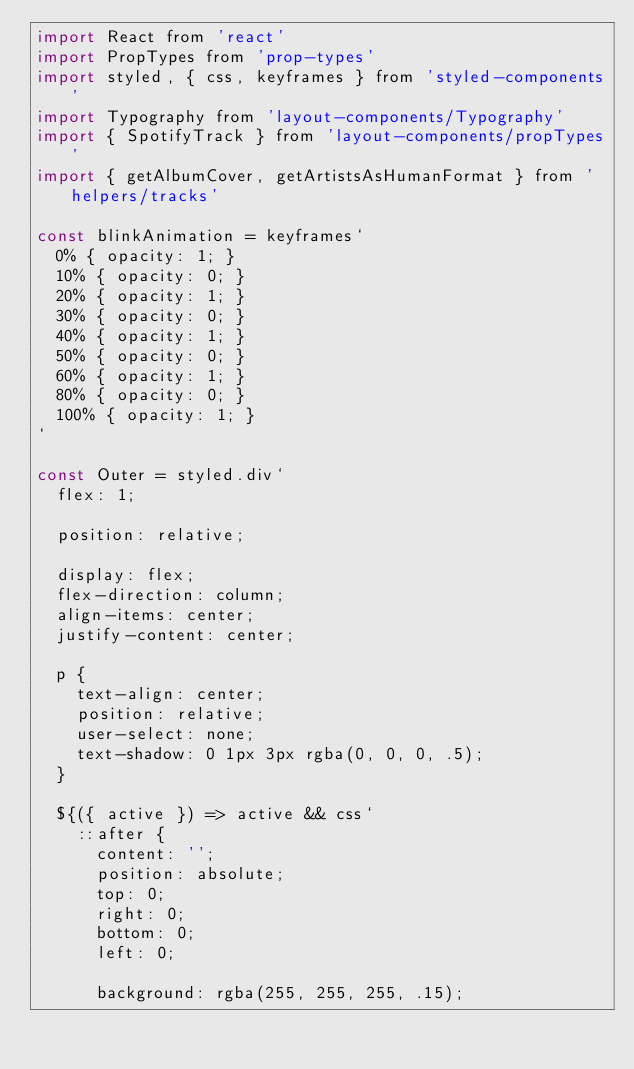<code> <loc_0><loc_0><loc_500><loc_500><_JavaScript_>import React from 'react'
import PropTypes from 'prop-types'
import styled, { css, keyframes } from 'styled-components'
import Typography from 'layout-components/Typography'
import { SpotifyTrack } from 'layout-components/propTypes'
import { getAlbumCover, getArtistsAsHumanFormat } from 'helpers/tracks'

const blinkAnimation = keyframes`
  0% { opacity: 1; }
  10% { opacity: 0; }
  20% { opacity: 1; }
  30% { opacity: 0; }
  40% { opacity: 1; }
  50% { opacity: 0; }
  60% { opacity: 1; }
  80% { opacity: 0; }
  100% { opacity: 1; }
`

const Outer = styled.div`
  flex: 1;

  position: relative;

  display: flex;
  flex-direction: column;
  align-items: center;
  justify-content: center;

  p {
    text-align: center;
    position: relative;
    user-select: none;
    text-shadow: 0 1px 3px rgba(0, 0, 0, .5);
  }

  ${({ active }) => active && css`
    ::after {
      content: '';
      position: absolute;
      top: 0;
      right: 0;
      bottom: 0;
      left: 0;

      background: rgba(255, 255, 255, .15);</code> 